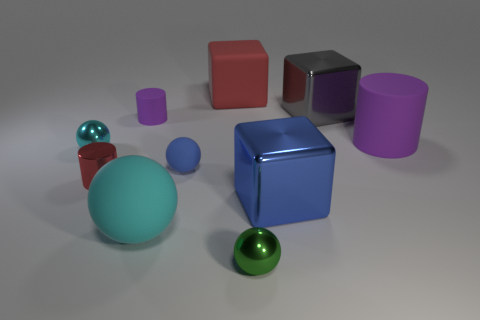Subtract all purple spheres. Subtract all blue blocks. How many spheres are left? 4 Subtract all cylinders. How many objects are left? 7 Add 1 purple rubber blocks. How many purple rubber blocks exist? 1 Subtract 0 brown cylinders. How many objects are left? 10 Subtract all small matte balls. Subtract all tiny metallic objects. How many objects are left? 6 Add 7 blue things. How many blue things are left? 9 